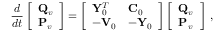<formula> <loc_0><loc_0><loc_500><loc_500>\frac { d } { d t } \left [ \begin{array} { l } { { Q } _ { v } } \\ { { P } _ { v } } \end{array} \right ] = \left [ \begin{array} { l l } { { Y } _ { 0 } ^ { T } } & { { C } _ { 0 } } \\ { - { V } _ { 0 } } & { - { Y } _ { 0 } } \end{array} \right ] \left [ \begin{array} { l } { { Q } _ { v } } \\ { { P } _ { v } } \end{array} \right ] \, ,</formula> 